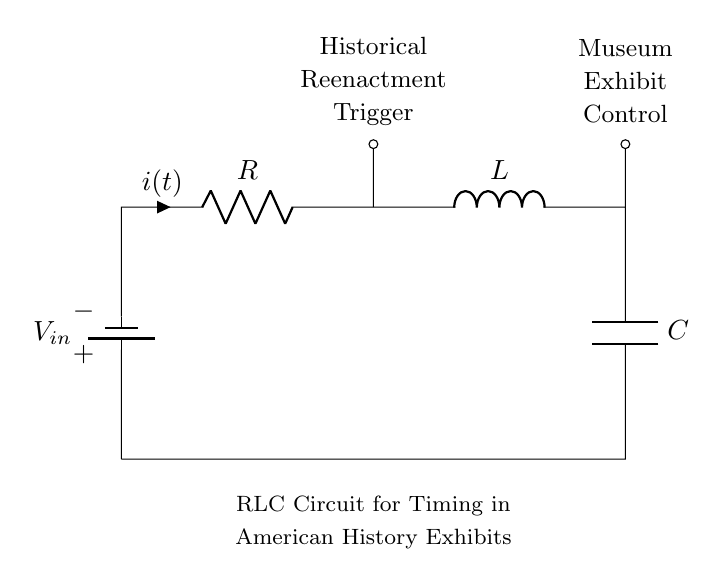What components are present in this circuit? The circuit consists of a battery, a resistor, an inductor, and a capacitor. By examining the diagram, you can identify each element labeled clearly: the battery is marked as the voltage source, the resistor is labeled R, the inductor is marked L, and the capacitor is shown as C.
Answer: battery, resistor, inductor, capacitor What is the primary function of this RLC circuit? The primary function of this RLC circuit is timing. The circuit is designed to create delays or control timing mechanisms, which is indicated by the description at the bottom of the diagram stating that it is for timing in American history exhibits.
Answer: timing Where does the input voltage connect in the circuit? The input voltage connects to the positive terminal of the battery at the top of the circuit. This is verified by noting the placement of the battery symbol at the left side of the diagram, showing the voltage source connected at the top level.
Answer: battery What can be inferred about the current direction in the circuit? The current direction flows from the positive terminal of the battery, through the resistor, then to the inductor, and finally into the capacitor before returning to the battery. This is deduced by the arrow indicating current flow in the circuit diagram and the sequential arrangement of components.
Answer: clockwise What is the role of the inductor in this circuit? The inductor's role in this circuit is to store energy in a magnetic field when current passes through it. This function is crucial for the timing aspect as inductors can introduce phase shifts and affect the charging and discharging cycle in the circuit.
Answer: store energy What is one potential application of this RLC circuit in a historical context? One potential application is for a historical reenactment trigger, which could activate sound or visual effects during a demonstration. This can be linked to the labeled section of the circuit that denotes a historical reenactment trigger, indicating its practical use in showcasing technology.
Answer: historical reenactment trigger 